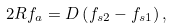<formula> <loc_0><loc_0><loc_500><loc_500>2 R f _ { a } = D \left ( f _ { s 2 } - f _ { s 1 } \right ) ,</formula> 